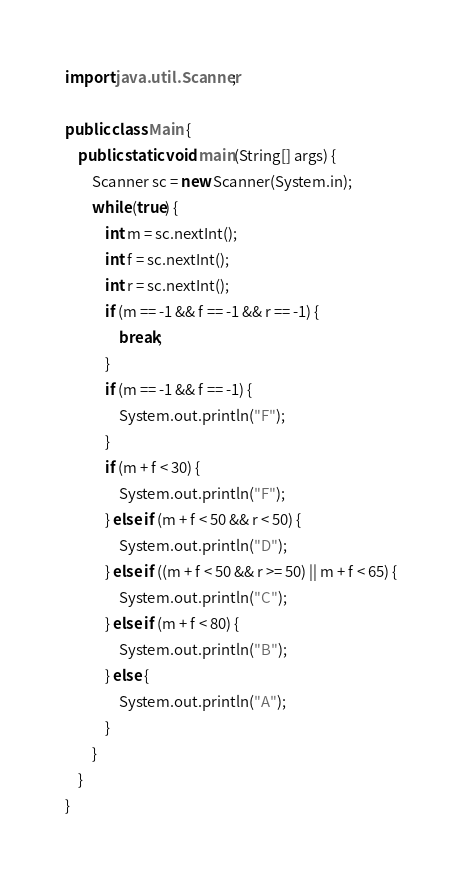<code> <loc_0><loc_0><loc_500><loc_500><_Java_>import java.util.Scanner;

public class Main {
	public static void main(String[] args) {
		Scanner sc = new Scanner(System.in);
		while (true) {
			int m = sc.nextInt();
			int f = sc.nextInt();
			int r = sc.nextInt();
			if (m == -1 && f == -1 && r == -1) {
				break;
			}
			if (m == -1 && f == -1) {
				System.out.println("F");
			}
			if (m + f < 30) {
				System.out.println("F");
			} else if (m + f < 50 && r < 50) {
				System.out.println("D");
			} else if ((m + f < 50 && r >= 50) || m + f < 65) {
				System.out.println("C");
			} else if (m + f < 80) {
				System.out.println("B");
			} else {
				System.out.println("A");
			}
		}
	}
}</code> 